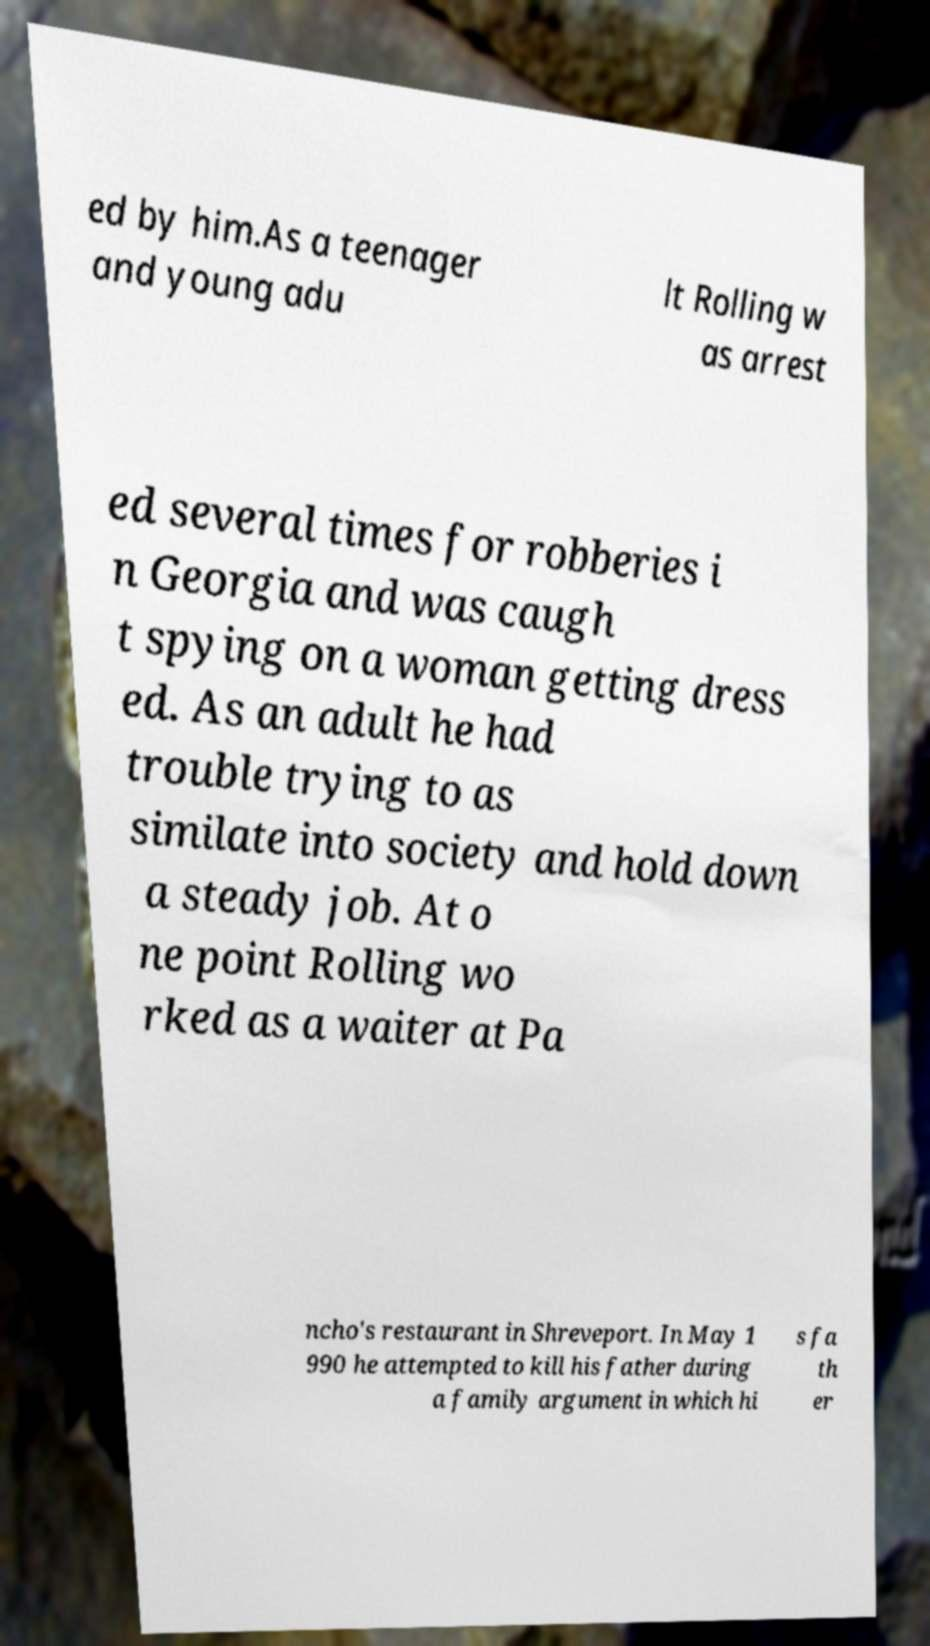For documentation purposes, I need the text within this image transcribed. Could you provide that? ed by him.As a teenager and young adu lt Rolling w as arrest ed several times for robberies i n Georgia and was caugh t spying on a woman getting dress ed. As an adult he had trouble trying to as similate into society and hold down a steady job. At o ne point Rolling wo rked as a waiter at Pa ncho's restaurant in Shreveport. In May 1 990 he attempted to kill his father during a family argument in which hi s fa th er 